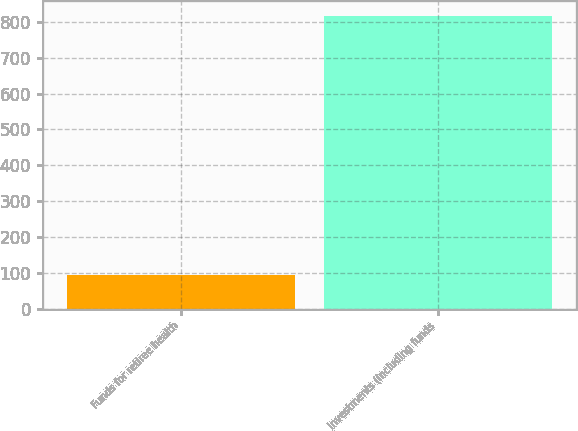Convert chart to OTSL. <chart><loc_0><loc_0><loc_500><loc_500><bar_chart><fcel>Funds for retiree health<fcel>Investments (including funds<nl><fcel>94<fcel>816<nl></chart> 